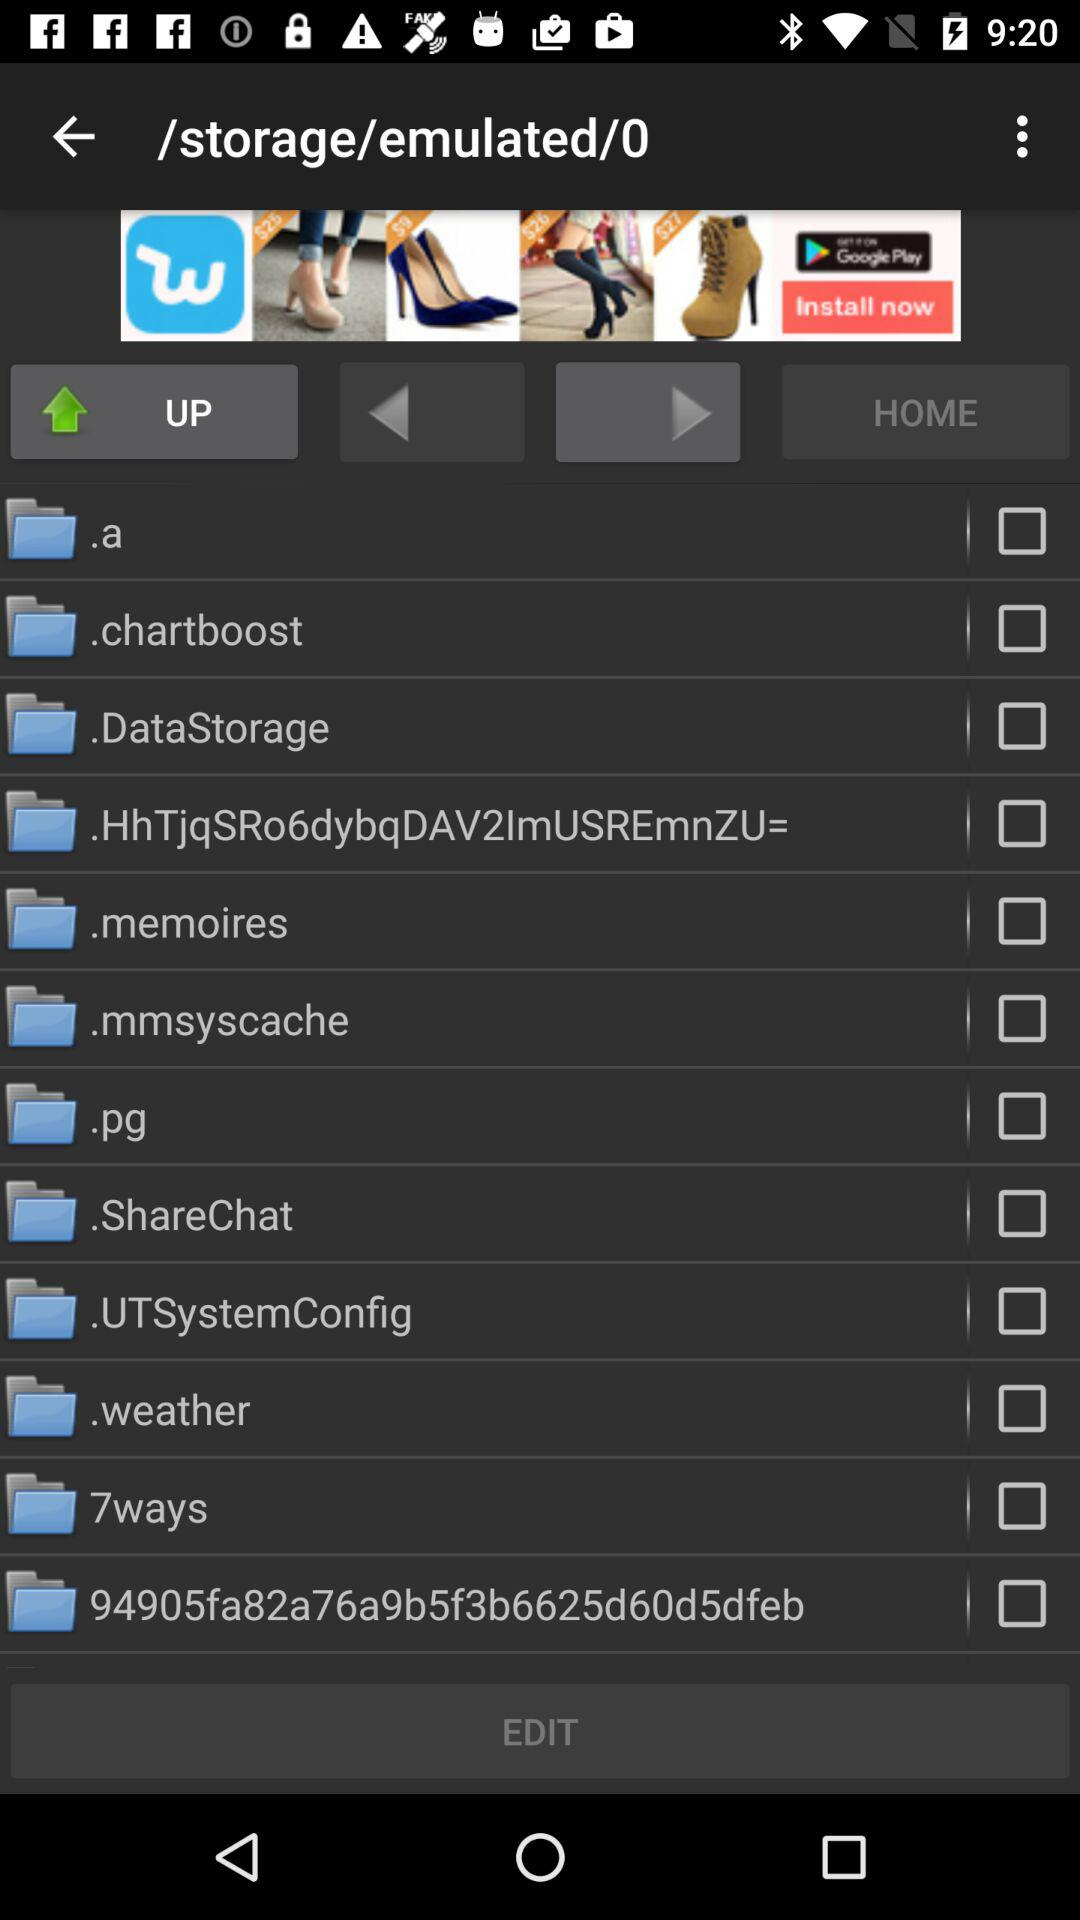What is the status of ".chartboost"? The status is "off". 